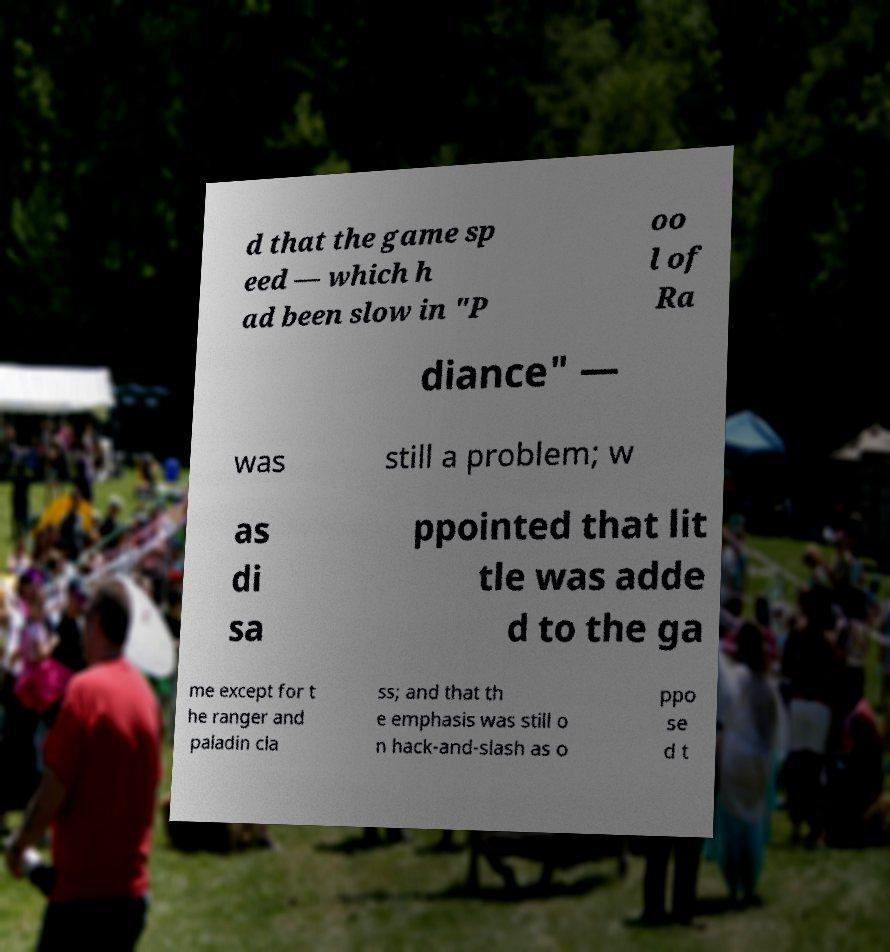Can you accurately transcribe the text from the provided image for me? d that the game sp eed — which h ad been slow in "P oo l of Ra diance" — was still a problem; w as di sa ppointed that lit tle was adde d to the ga me except for t he ranger and paladin cla ss; and that th e emphasis was still o n hack-and-slash as o ppo se d t 